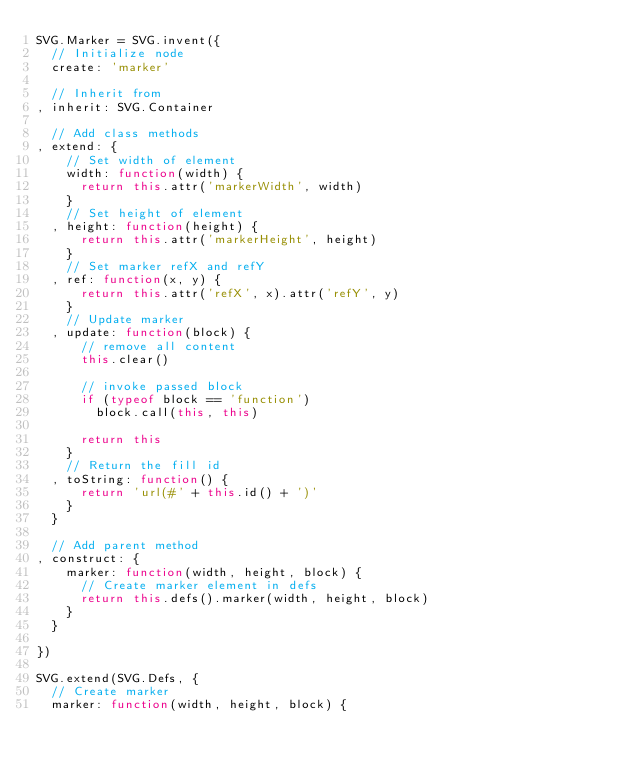<code> <loc_0><loc_0><loc_500><loc_500><_JavaScript_>SVG.Marker = SVG.invent({
  // Initialize node
  create: 'marker'

  // Inherit from
, inherit: SVG.Container

  // Add class methods
, extend: {
    // Set width of element
    width: function(width) {
      return this.attr('markerWidth', width)
    }
    // Set height of element
  , height: function(height) {
      return this.attr('markerHeight', height)
    }
    // Set marker refX and refY
  , ref: function(x, y) {
      return this.attr('refX', x).attr('refY', y)
    }
    // Update marker
  , update: function(block) {
      // remove all content 
      this.clear()
      
      // invoke passed block 
      if (typeof block == 'function')
        block.call(this, this)
      
      return this
    }
    // Return the fill id
  , toString: function() {
      return 'url(#' + this.id() + ')'
    }
  }

  // Add parent method
, construct: {
    marker: function(width, height, block) {
      // Create marker element in defs
      return this.defs().marker(width, height, block)
    }
  }

})

SVG.extend(SVG.Defs, {
  // Create marker
  marker: function(width, height, block) {</code> 